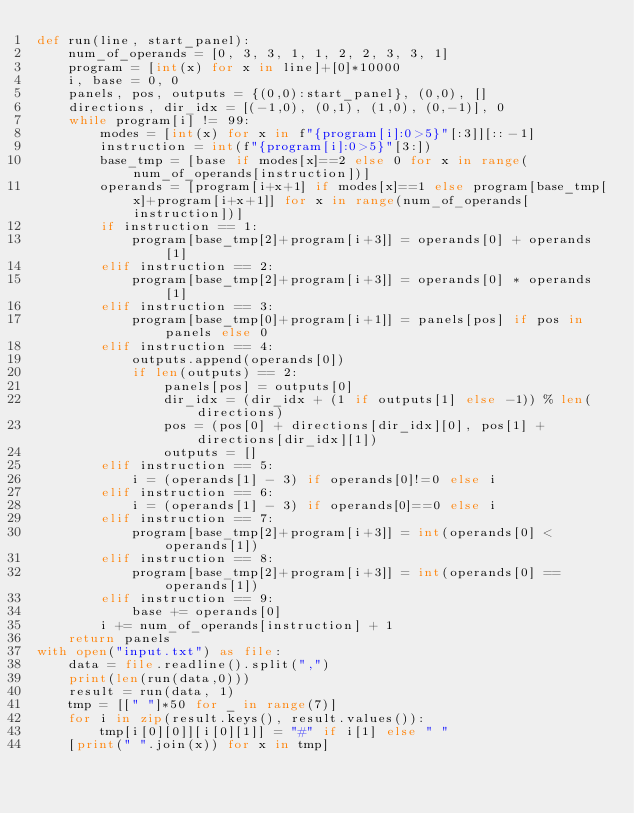<code> <loc_0><loc_0><loc_500><loc_500><_Python_>def run(line, start_panel):
    num_of_operands = [0, 3, 3, 1, 1, 2, 2, 3, 3, 1]
    program = [int(x) for x in line]+[0]*10000
    i, base = 0, 0
    panels, pos, outputs = {(0,0):start_panel}, (0,0), []
    directions, dir_idx = [(-1,0), (0,1), (1,0), (0,-1)], 0
    while program[i] != 99:
        modes = [int(x) for x in f"{program[i]:0>5}"[:3]][::-1]
        instruction = int(f"{program[i]:0>5}"[3:])
        base_tmp = [base if modes[x]==2 else 0 for x in range(num_of_operands[instruction])]
        operands = [program[i+x+1] if modes[x]==1 else program[base_tmp[x]+program[i+x+1]] for x in range(num_of_operands[instruction])]
        if instruction == 1:
            program[base_tmp[2]+program[i+3]] = operands[0] + operands[1]
        elif instruction == 2:
            program[base_tmp[2]+program[i+3]] = operands[0] * operands[1]
        elif instruction == 3:
            program[base_tmp[0]+program[i+1]] = panels[pos] if pos in panels else 0
        elif instruction == 4:
            outputs.append(operands[0])
            if len(outputs) == 2:
                panels[pos] = outputs[0]
                dir_idx = (dir_idx + (1 if outputs[1] else -1)) % len(directions)
                pos = (pos[0] + directions[dir_idx][0], pos[1] + directions[dir_idx][1])
                outputs = []
        elif instruction == 5:
            i = (operands[1] - 3) if operands[0]!=0 else i
        elif instruction == 6:
            i = (operands[1] - 3) if operands[0]==0 else i
        elif instruction == 7:
            program[base_tmp[2]+program[i+3]] = int(operands[0] < operands[1])
        elif instruction == 8:
            program[base_tmp[2]+program[i+3]] = int(operands[0] == operands[1])
        elif instruction == 9:
            base += operands[0]
        i += num_of_operands[instruction] + 1
    return panels
with open("input.txt") as file:
    data = file.readline().split(",")
    print(len(run(data,0)))
    result = run(data, 1)
    tmp = [[" "]*50 for _ in range(7)]
    for i in zip(result.keys(), result.values()):
        tmp[i[0][0]][i[0][1]] = "#" if i[1] else " "
    [print(" ".join(x)) for x in tmp]</code> 